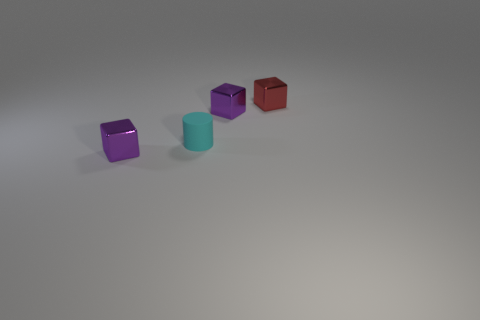Is there anything else that is the same size as the cyan matte cylinder?
Your response must be concise. Yes. Do the cyan object and the small red shiny thing have the same shape?
Your answer should be very brief. No. How many tiny shiny objects are right of the matte cylinder and to the left of the red thing?
Your answer should be compact. 1. What number of matte things are tiny purple objects or small red things?
Offer a terse response. 0. There is a purple object right of the tiny purple object that is left of the matte cylinder; what is its size?
Ensure brevity in your answer.  Small. There is a tiny purple cube that is to the right of the tiny purple cube in front of the tiny cyan matte cylinder; is there a block that is behind it?
Your answer should be compact. Yes. Are the red object behind the tiny cyan rubber object and the tiny object in front of the rubber cylinder made of the same material?
Ensure brevity in your answer.  Yes. How many objects are big purple rubber cubes or small cubes that are left of the red metal block?
Keep it short and to the point. 2. How many tiny purple shiny things have the same shape as the small red metallic object?
Your answer should be very brief. 2. There is a red object that is the same size as the cyan rubber cylinder; what is it made of?
Your response must be concise. Metal. 